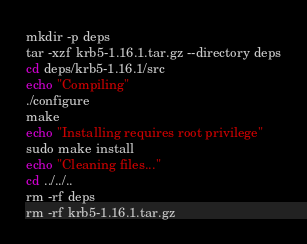Convert code to text. <code><loc_0><loc_0><loc_500><loc_500><_Bash_>mkdir -p deps
tar -xzf krb5-1.16.1.tar.gz --directory deps
cd deps/krb5-1.16.1/src
echo "Compiling"
./configure
make
echo "Installing requires root privilege"
sudo make install
echo "Cleaning files..."
cd ../../..
rm -rf deps
rm -rf krb5-1.16.1.tar.gz
</code> 